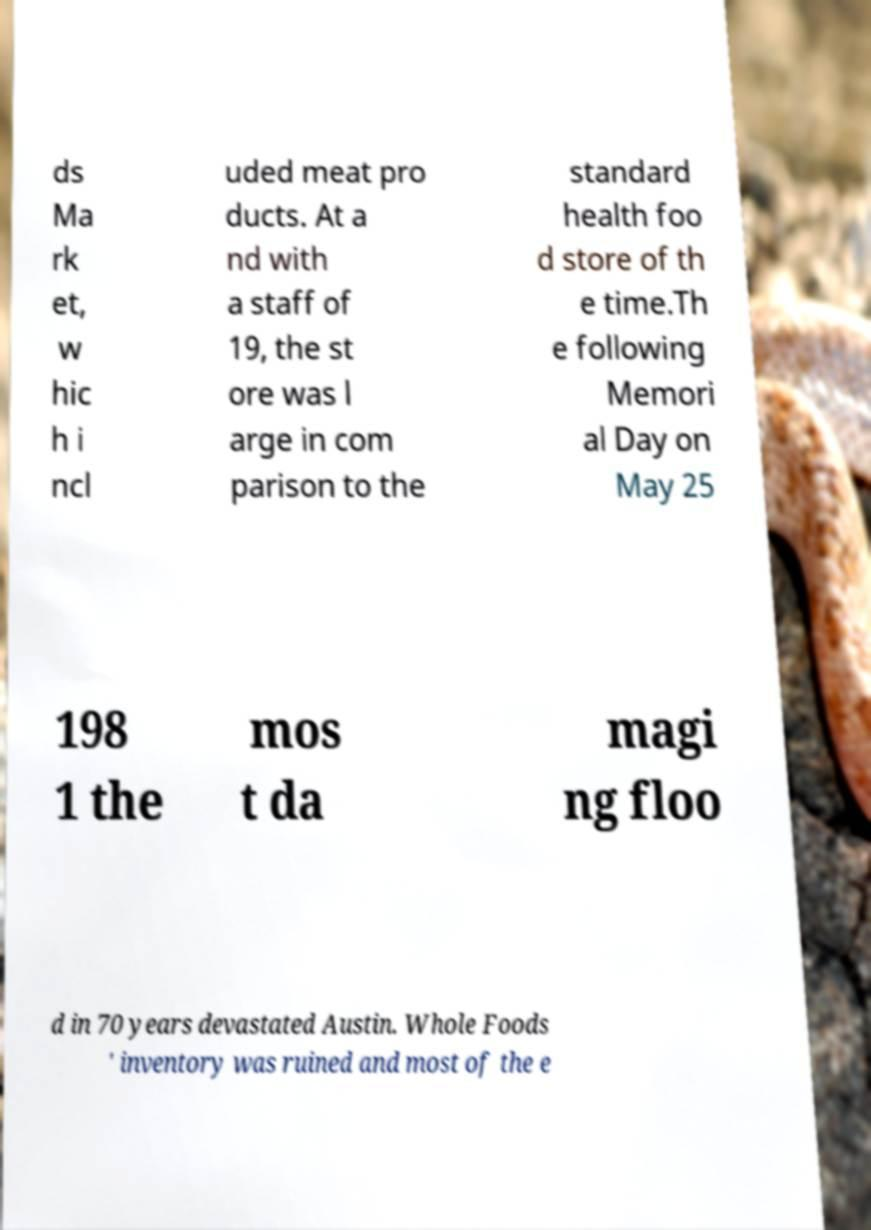Could you assist in decoding the text presented in this image and type it out clearly? ds Ma rk et, w hic h i ncl uded meat pro ducts. At a nd with a staff of 19, the st ore was l arge in com parison to the standard health foo d store of th e time.Th e following Memori al Day on May 25 198 1 the mos t da magi ng floo d in 70 years devastated Austin. Whole Foods ' inventory was ruined and most of the e 